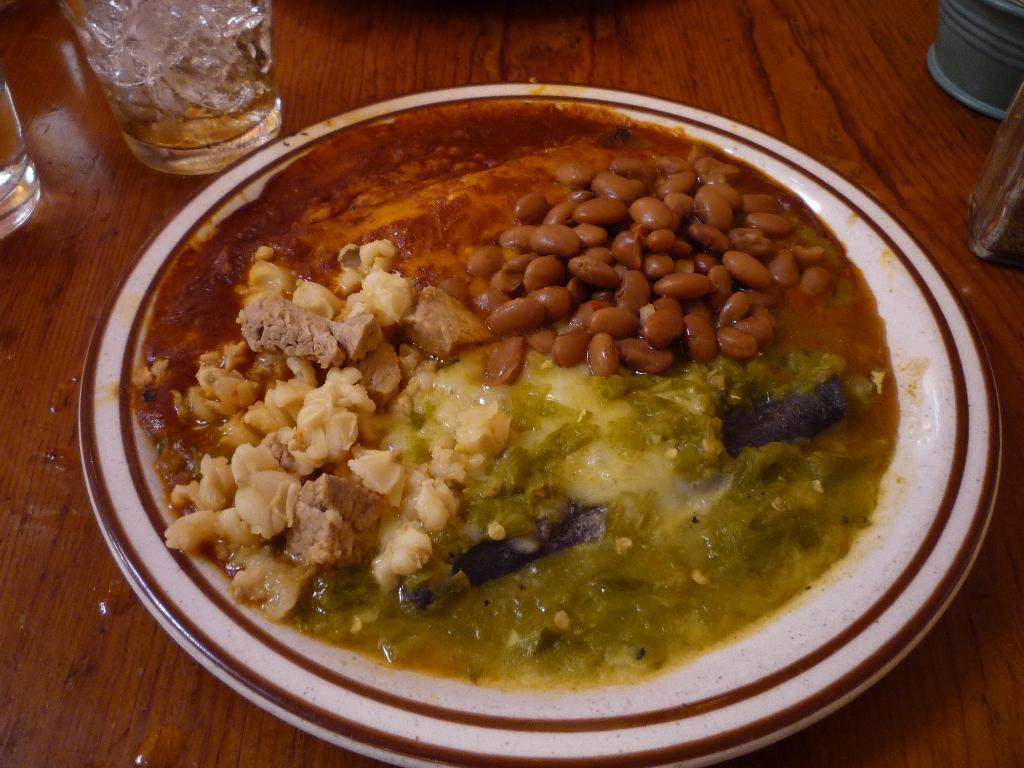Could you give a brief overview of what you see in this image? In the picture we can see some food item which is in white color plate and we can see some glasses which are on the wooden surface. 